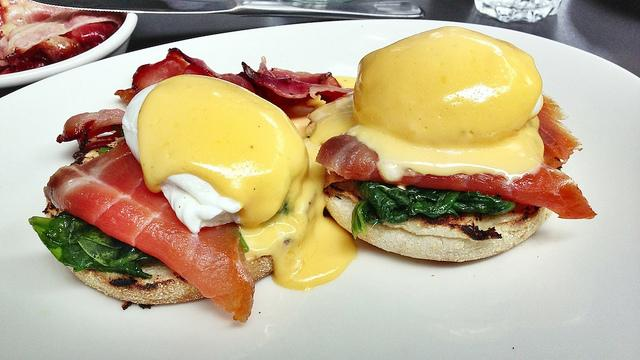What type of egg dish is shown?

Choices:
A) fu yung
B) benedict
C) scrambled
D) omelette benedict 